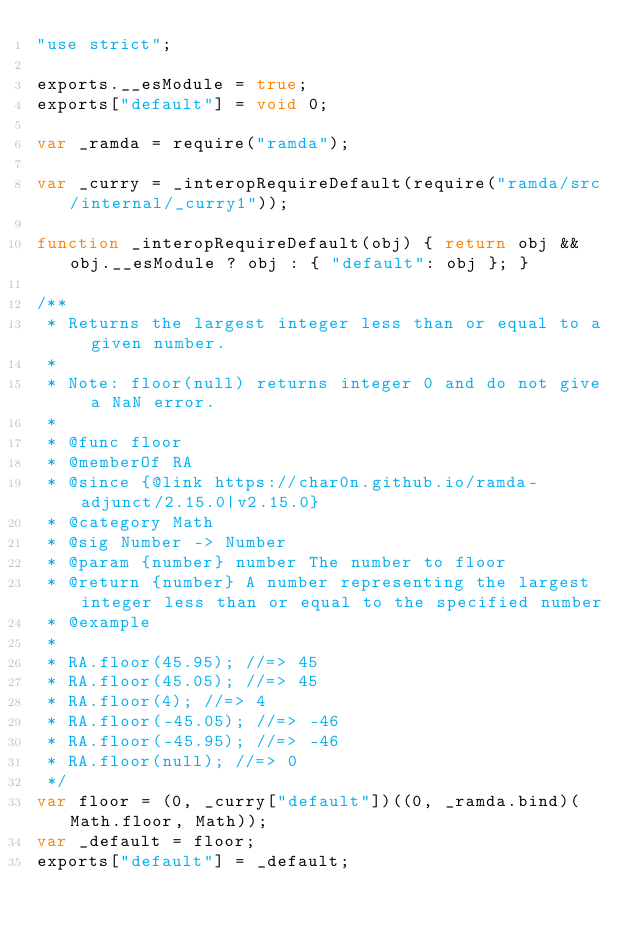<code> <loc_0><loc_0><loc_500><loc_500><_JavaScript_>"use strict";

exports.__esModule = true;
exports["default"] = void 0;

var _ramda = require("ramda");

var _curry = _interopRequireDefault(require("ramda/src/internal/_curry1"));

function _interopRequireDefault(obj) { return obj && obj.__esModule ? obj : { "default": obj }; }

/**
 * Returns the largest integer less than or equal to a given number.
 *
 * Note: floor(null) returns integer 0 and do not give a NaN error.
 *
 * @func floor
 * @memberOf RA
 * @since {@link https://char0n.github.io/ramda-adjunct/2.15.0|v2.15.0}
 * @category Math
 * @sig Number -> Number
 * @param {number} number The number to floor
 * @return {number} A number representing the largest integer less than or equal to the specified number
 * @example
 *
 * RA.floor(45.95); //=> 45
 * RA.floor(45.05); //=> 45
 * RA.floor(4); //=> 4
 * RA.floor(-45.05); //=> -46
 * RA.floor(-45.95); //=> -46
 * RA.floor(null); //=> 0
 */
var floor = (0, _curry["default"])((0, _ramda.bind)(Math.floor, Math));
var _default = floor;
exports["default"] = _default;</code> 